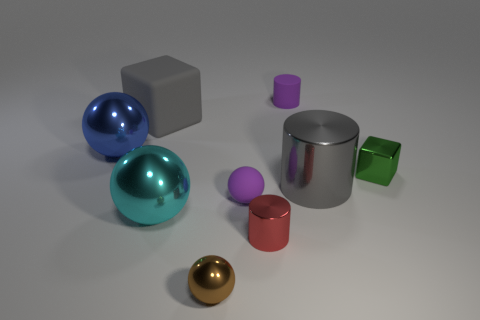Does the tiny rubber ball have the same color as the small cylinder behind the large cylinder?
Give a very brief answer. Yes. What is the size of the block that is in front of the blue sphere?
Offer a very short reply. Small. Are there fewer large metallic things than tiny cyan matte objects?
Give a very brief answer. No. Is there a thing of the same color as the small rubber cylinder?
Give a very brief answer. Yes. What shape is the small thing that is to the right of the purple rubber ball and in front of the big gray metallic object?
Keep it short and to the point. Cylinder. What is the shape of the matte object that is in front of the small metallic block behind the big cylinder?
Your response must be concise. Sphere. Is the big gray rubber thing the same shape as the small green thing?
Keep it short and to the point. Yes. There is another object that is the same color as the large rubber thing; what is it made of?
Provide a succinct answer. Metal. Is the color of the rubber sphere the same as the rubber cylinder?
Offer a terse response. Yes. What number of rubber objects are behind the purple thing that is in front of the large metal cylinder behind the tiny brown metallic object?
Offer a very short reply. 2. 